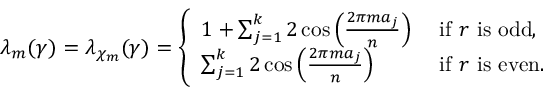Convert formula to latex. <formula><loc_0><loc_0><loc_500><loc_500>\lambda _ { m } ( \gamma ) = \lambda _ { \chi _ { m } } ( \gamma ) = \left \{ \begin{array} { l l } { 1 + \sum _ { j = 1 } ^ { k } 2 \cos \left ( \frac { 2 \pi m a _ { j } } { n } \right ) } & { i f r i s o d d , } \\ { \sum _ { j = 1 } ^ { k } 2 \cos \left ( \frac { 2 \pi m a _ { j } } { n } \right ) } & { i f r i s e v e n . } \end{array}</formula> 